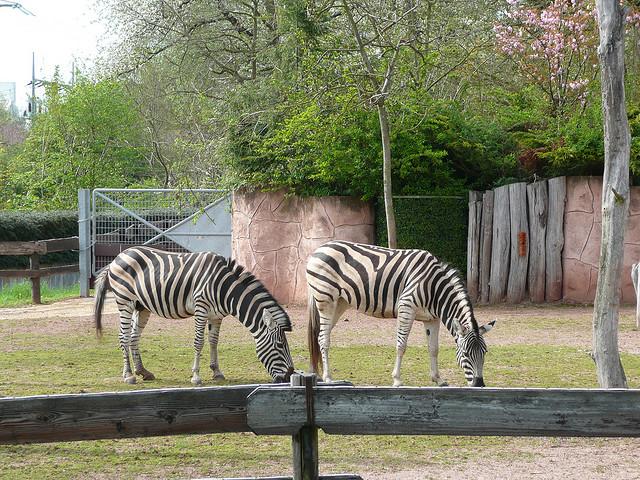Is this a farm?
Concise answer only. No. Do these zebra have enough room to roam and play in this enclosure?
Give a very brief answer. No. Is there an animal with horns anywhere?
Answer briefly. No. Are the animals eating?
Concise answer only. Yes. 